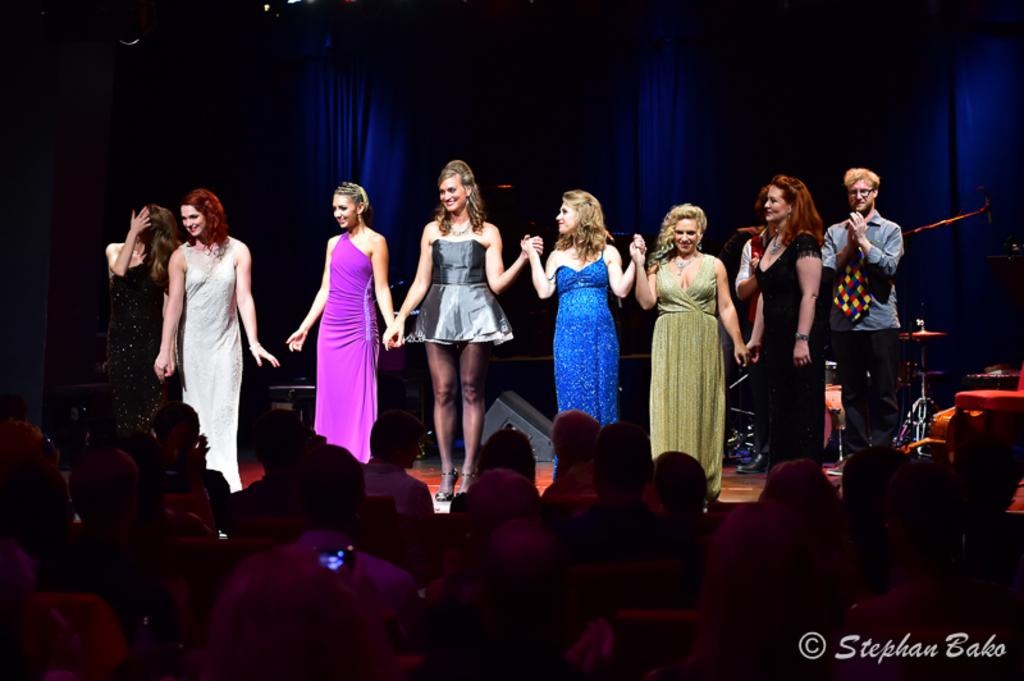What is happening in the image? There is a group of persons standing on the stage, and a group of people sitting at the bottom. Can you describe the setting of the image? The image appears to be taken at an event or performance, with a stage and an audience. Is there any text or logo visible in the image? Yes, there is a watermark in the bottom right-hand side of the image. How many beds are visible in the image? There are no beds visible in the image. What type of produce is being sold by the person standing on the stage? There is no produce or person selling produce in the image. 